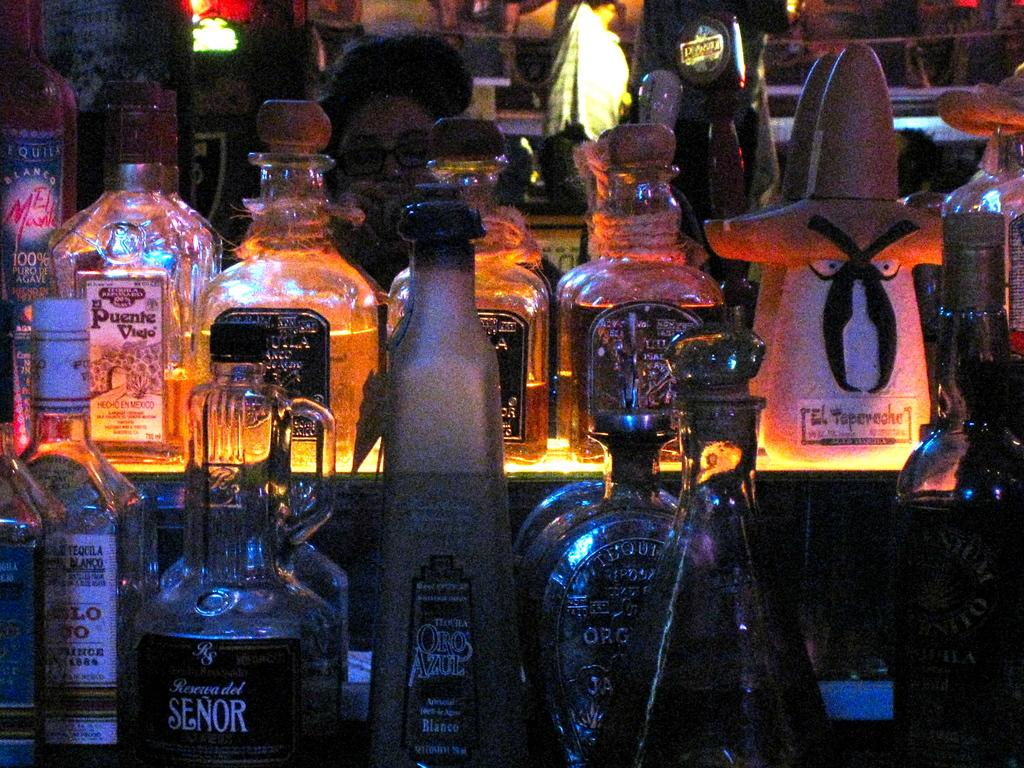What can be seen on the table in the image? There are wine bottles on the table in the image. Who or what is located behind the table in the image? There is a person sitting behind the table in the image. What type of sponge can be seen flying in the image? There is no sponge present in the image, and no object is depicted as flying. 